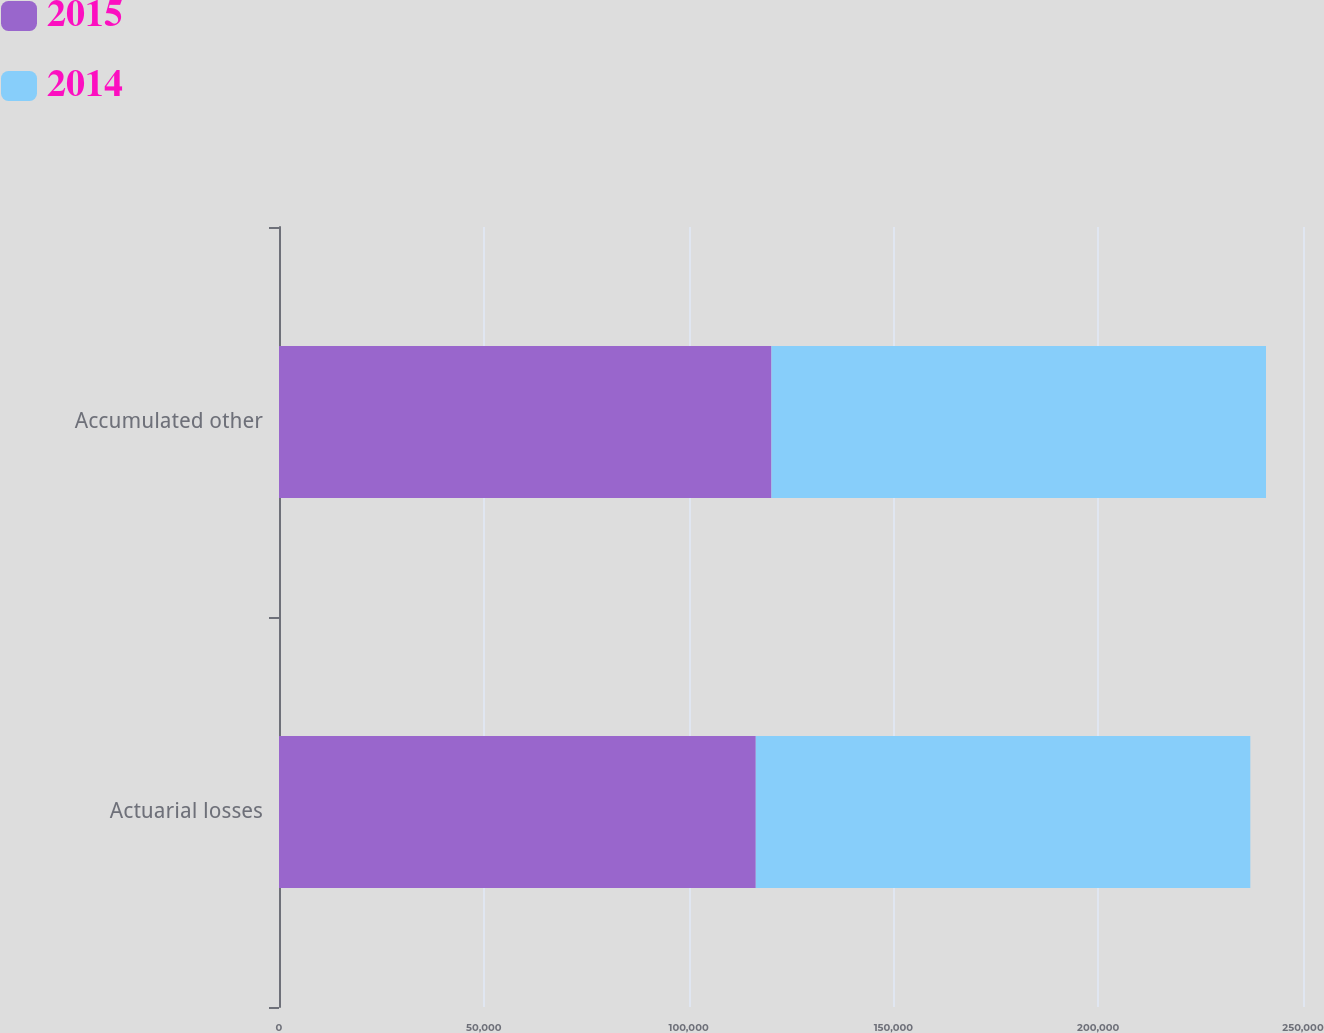Convert chart to OTSL. <chart><loc_0><loc_0><loc_500><loc_500><stacked_bar_chart><ecel><fcel>Actuarial losses<fcel>Accumulated other<nl><fcel>2015<fcel>116400<fcel>120230<nl><fcel>2014<fcel>120735<fcel>120735<nl></chart> 